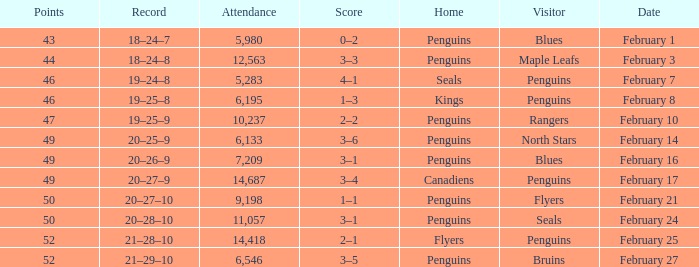Record of 21–29–10 had what total number of points? 1.0. 